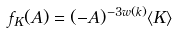Convert formula to latex. <formula><loc_0><loc_0><loc_500><loc_500>f _ { K } ( A ) = ( - A ) ^ { - 3 w ( k ) } \langle K \rangle</formula> 